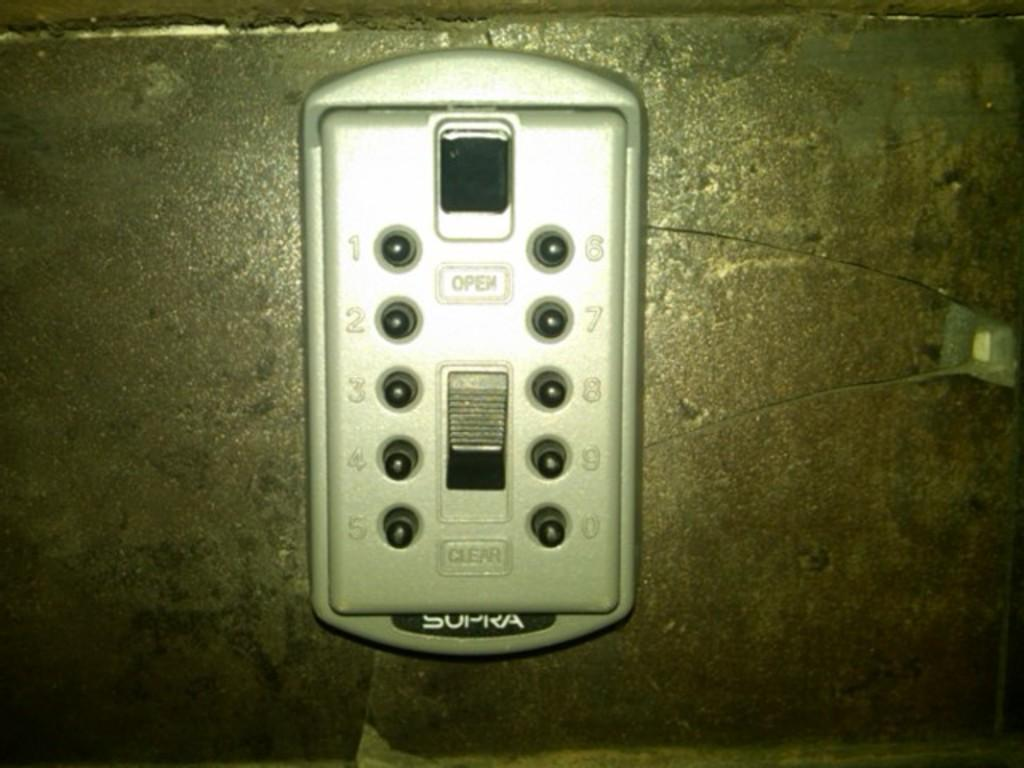<image>
Relay a brief, clear account of the picture shown. Some sort of electronic gadget that is white and says "open" on the front. 